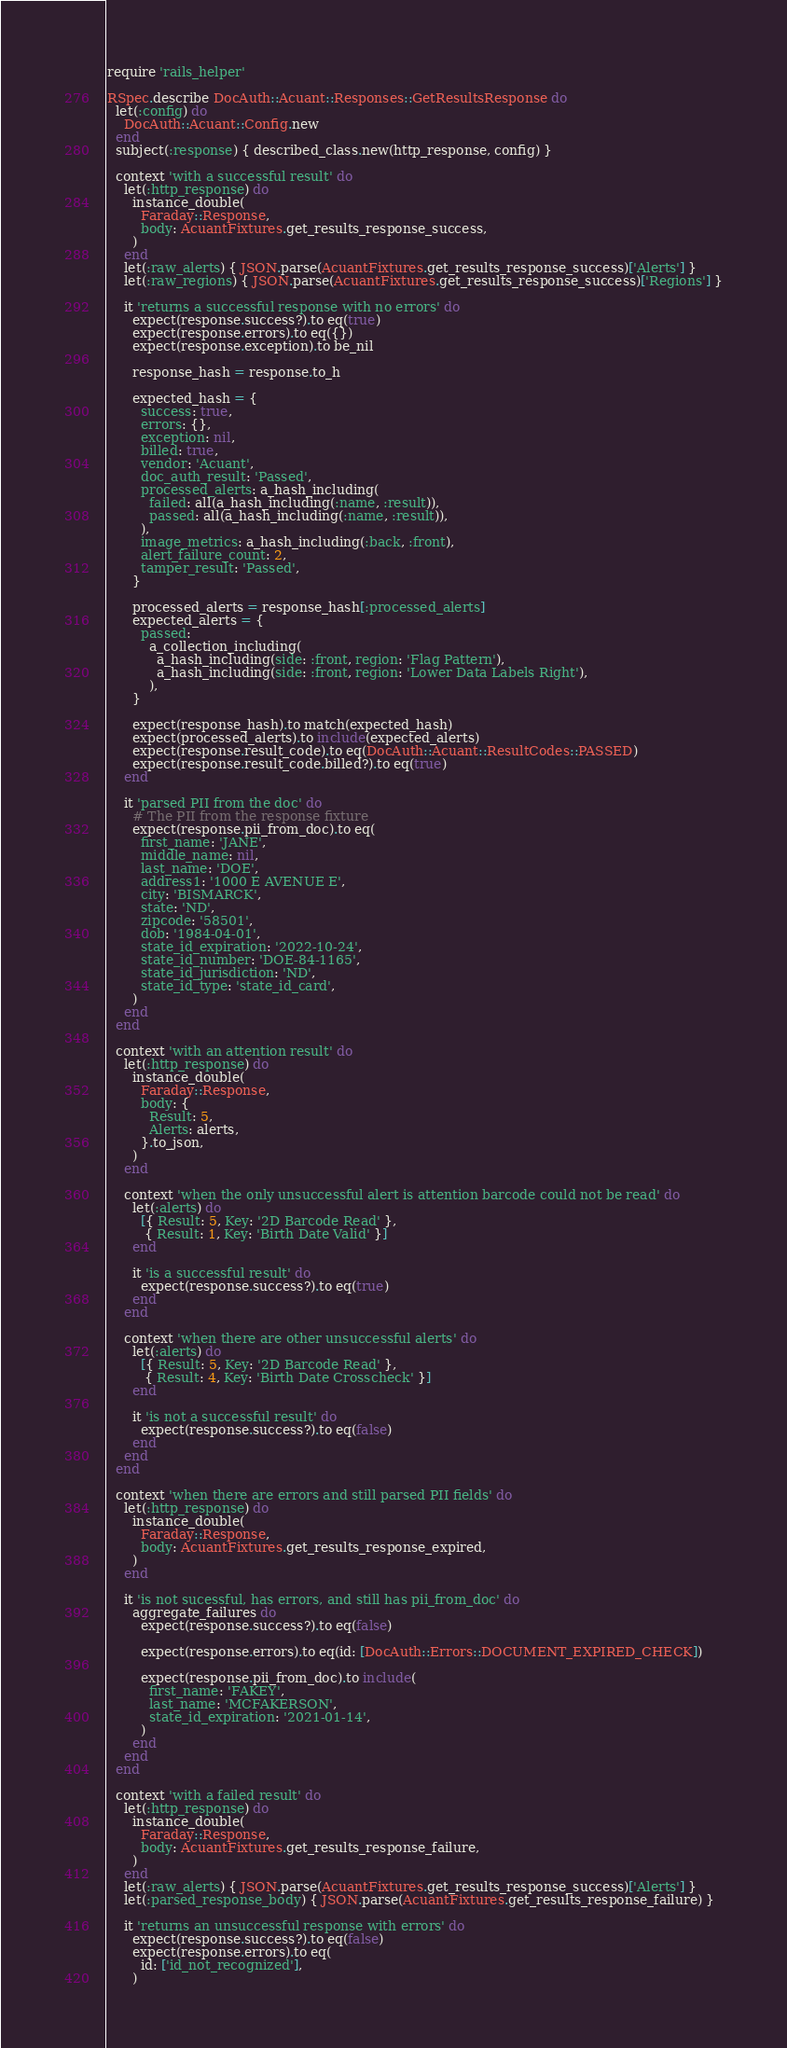Convert code to text. <code><loc_0><loc_0><loc_500><loc_500><_Ruby_>require 'rails_helper'

RSpec.describe DocAuth::Acuant::Responses::GetResultsResponse do
  let(:config) do
    DocAuth::Acuant::Config.new
  end
  subject(:response) { described_class.new(http_response, config) }

  context 'with a successful result' do
    let(:http_response) do
      instance_double(
        Faraday::Response,
        body: AcuantFixtures.get_results_response_success,
      )
    end
    let(:raw_alerts) { JSON.parse(AcuantFixtures.get_results_response_success)['Alerts'] }
    let(:raw_regions) { JSON.parse(AcuantFixtures.get_results_response_success)['Regions'] }

    it 'returns a successful response with no errors' do
      expect(response.success?).to eq(true)
      expect(response.errors).to eq({})
      expect(response.exception).to be_nil

      response_hash = response.to_h

      expected_hash = {
        success: true,
        errors: {},
        exception: nil,
        billed: true,
        vendor: 'Acuant',
        doc_auth_result: 'Passed',
        processed_alerts: a_hash_including(
          failed: all(a_hash_including(:name, :result)),
          passed: all(a_hash_including(:name, :result)),
        ),
        image_metrics: a_hash_including(:back, :front),
        alert_failure_count: 2,
        tamper_result: 'Passed',
      }

      processed_alerts = response_hash[:processed_alerts]
      expected_alerts = {
        passed:
          a_collection_including(
            a_hash_including(side: :front, region: 'Flag Pattern'),
            a_hash_including(side: :front, region: 'Lower Data Labels Right'),
          ),
      }

      expect(response_hash).to match(expected_hash)
      expect(processed_alerts).to include(expected_alerts)
      expect(response.result_code).to eq(DocAuth::Acuant::ResultCodes::PASSED)
      expect(response.result_code.billed?).to eq(true)
    end

    it 'parsed PII from the doc' do
      # The PII from the response fixture
      expect(response.pii_from_doc).to eq(
        first_name: 'JANE',
        middle_name: nil,
        last_name: 'DOE',
        address1: '1000 E AVENUE E',
        city: 'BISMARCK',
        state: 'ND',
        zipcode: '58501',
        dob: '1984-04-01',
        state_id_expiration: '2022-10-24',
        state_id_number: 'DOE-84-1165',
        state_id_jurisdiction: 'ND',
        state_id_type: 'state_id_card',
      )
    end
  end

  context 'with an attention result' do
    let(:http_response) do
      instance_double(
        Faraday::Response,
        body: {
          Result: 5,
          Alerts: alerts,
        }.to_json,
      )
    end

    context 'when the only unsuccessful alert is attention barcode could not be read' do
      let(:alerts) do
        [{ Result: 5, Key: '2D Barcode Read' },
         { Result: 1, Key: 'Birth Date Valid' }]
      end

      it 'is a successful result' do
        expect(response.success?).to eq(true)
      end
    end

    context 'when there are other unsuccessful alerts' do
      let(:alerts) do
        [{ Result: 5, Key: '2D Barcode Read' },
         { Result: 4, Key: 'Birth Date Crosscheck' }]
      end

      it 'is not a successful result' do
        expect(response.success?).to eq(false)
      end
    end
  end

  context 'when there are errors and still parsed PII fields' do
    let(:http_response) do
      instance_double(
        Faraday::Response,
        body: AcuantFixtures.get_results_response_expired,
      )
    end

    it 'is not sucessful, has errors, and still has pii_from_doc' do
      aggregate_failures do
        expect(response.success?).to eq(false)

        expect(response.errors).to eq(id: [DocAuth::Errors::DOCUMENT_EXPIRED_CHECK])

        expect(response.pii_from_doc).to include(
          first_name: 'FAKEY',
          last_name: 'MCFAKERSON',
          state_id_expiration: '2021-01-14',
        )
      end
    end
  end

  context 'with a failed result' do
    let(:http_response) do
      instance_double(
        Faraday::Response,
        body: AcuantFixtures.get_results_response_failure,
      )
    end
    let(:raw_alerts) { JSON.parse(AcuantFixtures.get_results_response_success)['Alerts'] }
    let(:parsed_response_body) { JSON.parse(AcuantFixtures.get_results_response_failure) }

    it 'returns an unsuccessful response with errors' do
      expect(response.success?).to eq(false)
      expect(response.errors).to eq(
        id: ['id_not_recognized'],
      )</code> 